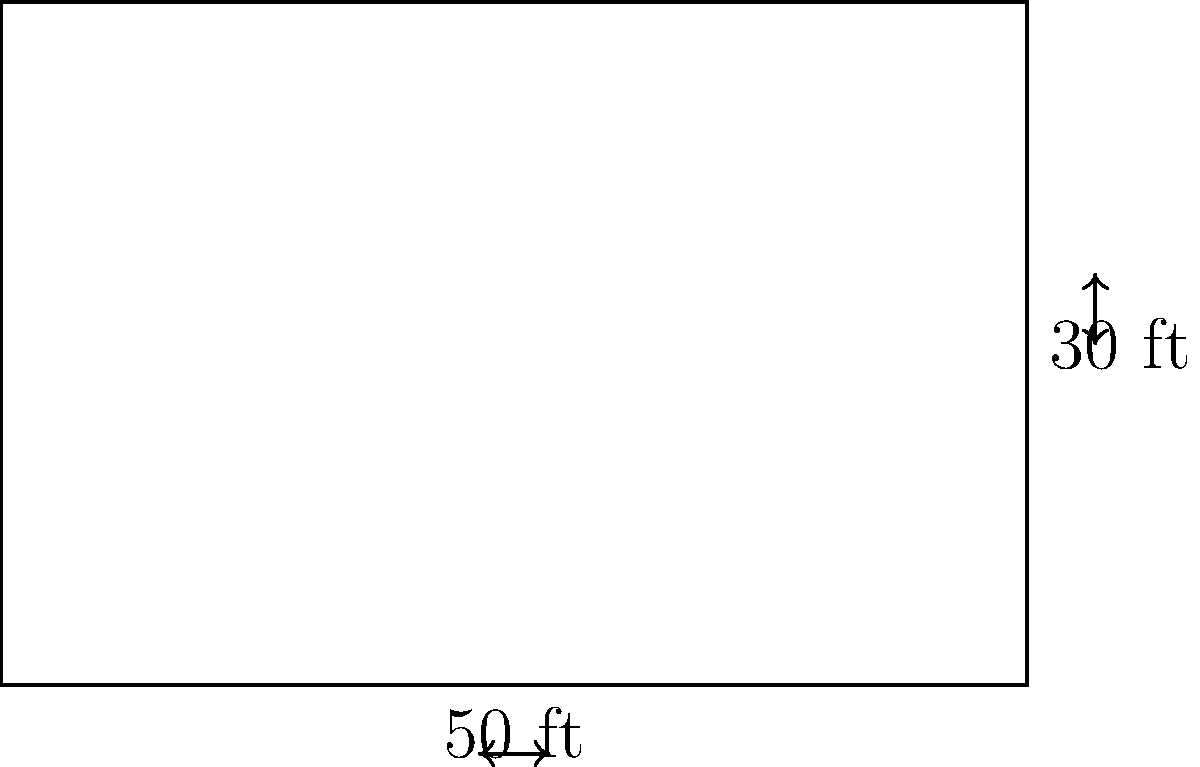A retirement home is planning to install a rectangular patio for its residents. The patio will be 50 feet long and 30 feet wide, as shown in the diagram. To ensure safety, the home wants to install a fence around the entire perimeter of the patio. If the fencing costs $15 per linear foot, what will be the total cost of the fencing project? To solve this problem, we'll follow these steps:

1. Calculate the perimeter of the rectangular patio:
   - Perimeter = 2 × (length + width)
   - Perimeter = 2 × (50 ft + 30 ft)
   - Perimeter = 2 × 80 ft = 160 ft

2. Calculate the cost of fencing:
   - Cost per linear foot = $15
   - Total cost = Perimeter × Cost per linear foot
   - Total cost = 160 ft × $15/ft = $2,400

Therefore, the total cost of the fencing project for the retirement home's patio will be $2,400.
Answer: $2,400 